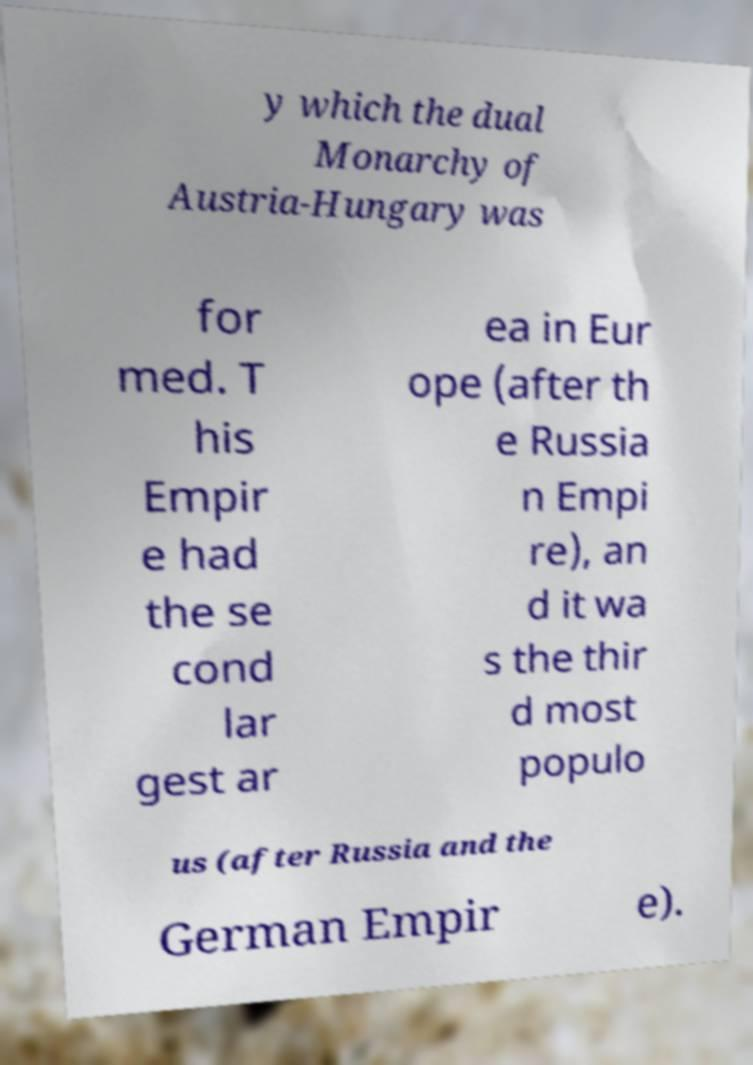Could you assist in decoding the text presented in this image and type it out clearly? y which the dual Monarchy of Austria-Hungary was for med. T his Empir e had the se cond lar gest ar ea in Eur ope (after th e Russia n Empi re), an d it wa s the thir d most populo us (after Russia and the German Empir e). 